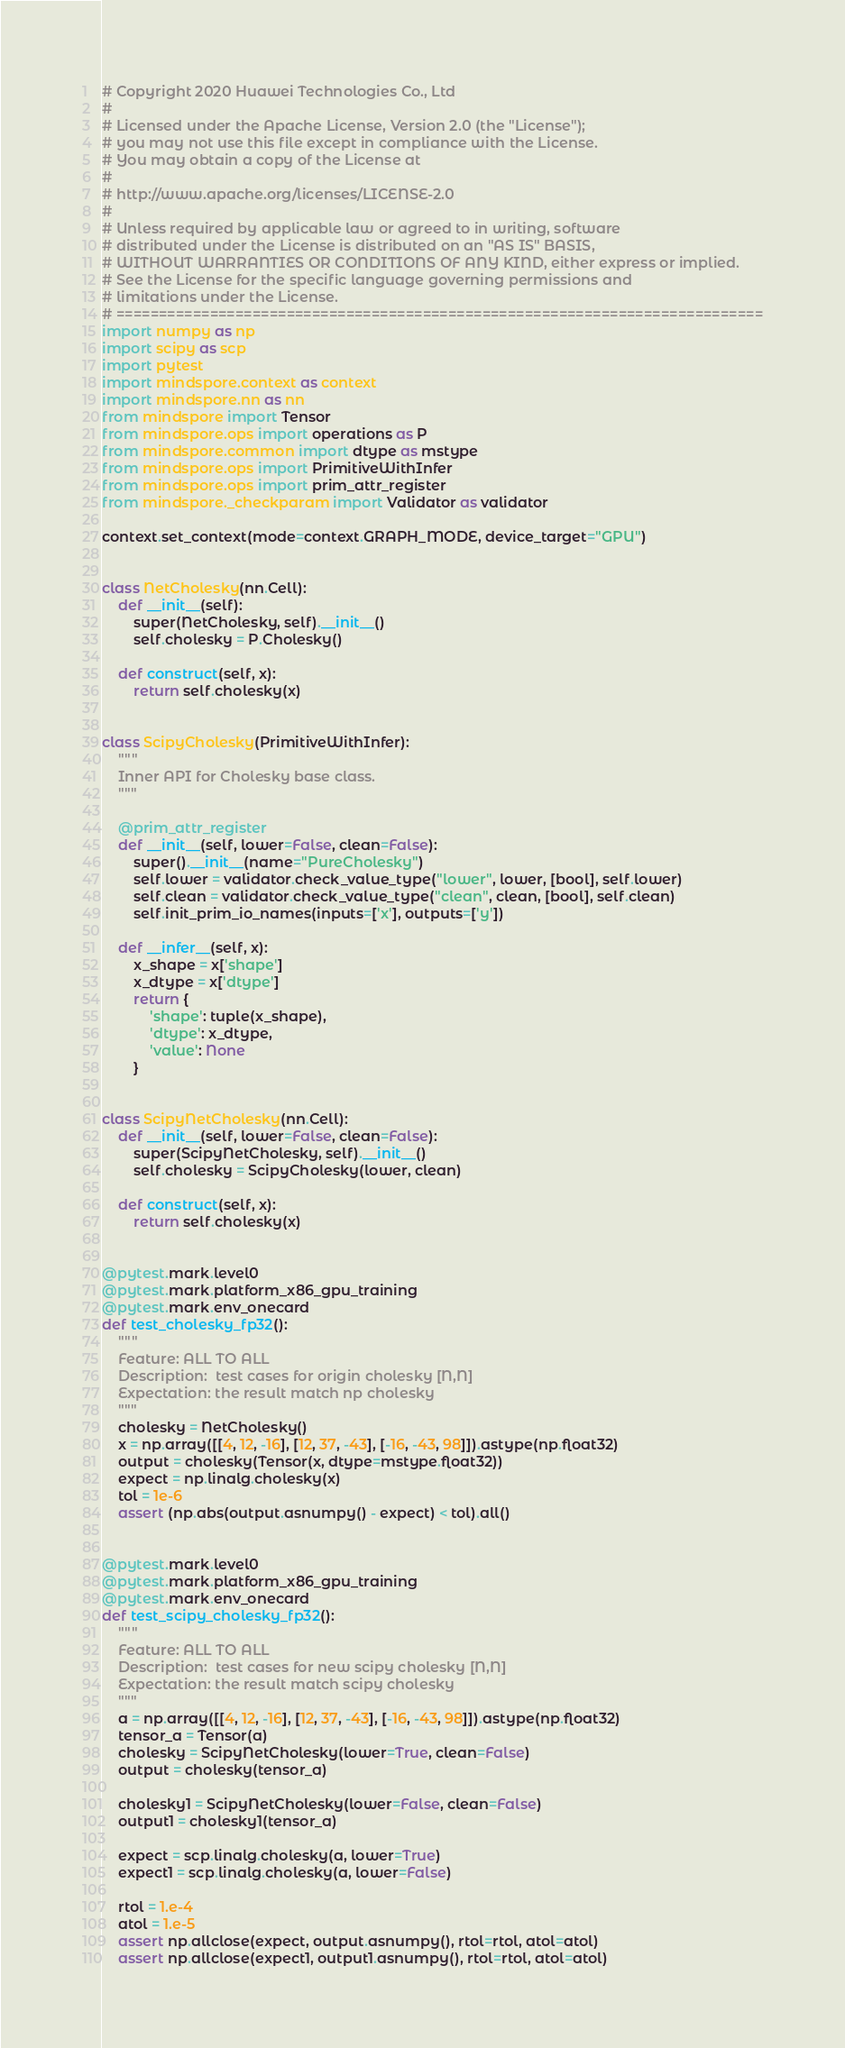<code> <loc_0><loc_0><loc_500><loc_500><_Python_># Copyright 2020 Huawei Technologies Co., Ltd
#
# Licensed under the Apache License, Version 2.0 (the "License");
# you may not use this file except in compliance with the License.
# You may obtain a copy of the License at
#
# http://www.apache.org/licenses/LICENSE-2.0
#
# Unless required by applicable law or agreed to in writing, software
# distributed under the License is distributed on an "AS IS" BASIS,
# WITHOUT WARRANTIES OR CONDITIONS OF ANY KIND, either express or implied.
# See the License for the specific language governing permissions and
# limitations under the License.
# ============================================================================
import numpy as np
import scipy as scp
import pytest
import mindspore.context as context
import mindspore.nn as nn
from mindspore import Tensor
from mindspore.ops import operations as P
from mindspore.common import dtype as mstype
from mindspore.ops import PrimitiveWithInfer
from mindspore.ops import prim_attr_register
from mindspore._checkparam import Validator as validator

context.set_context(mode=context.GRAPH_MODE, device_target="GPU")


class NetCholesky(nn.Cell):
    def __init__(self):
        super(NetCholesky, self).__init__()
        self.cholesky = P.Cholesky()

    def construct(self, x):
        return self.cholesky(x)


class ScipyCholesky(PrimitiveWithInfer):
    """
    Inner API for Cholesky base class.
    """

    @prim_attr_register
    def __init__(self, lower=False, clean=False):
        super().__init__(name="PureCholesky")
        self.lower = validator.check_value_type("lower", lower, [bool], self.lower)
        self.clean = validator.check_value_type("clean", clean, [bool], self.clean)
        self.init_prim_io_names(inputs=['x'], outputs=['y'])

    def __infer__(self, x):
        x_shape = x['shape']
        x_dtype = x['dtype']
        return {
            'shape': tuple(x_shape),
            'dtype': x_dtype,
            'value': None
        }


class ScipyNetCholesky(nn.Cell):
    def __init__(self, lower=False, clean=False):
        super(ScipyNetCholesky, self).__init__()
        self.cholesky = ScipyCholesky(lower, clean)

    def construct(self, x):
        return self.cholesky(x)


@pytest.mark.level0
@pytest.mark.platform_x86_gpu_training
@pytest.mark.env_onecard
def test_cholesky_fp32():
    """
    Feature: ALL TO ALL
    Description:  test cases for origin cholesky [N,N]
    Expectation: the result match np cholesky
    """
    cholesky = NetCholesky()
    x = np.array([[4, 12, -16], [12, 37, -43], [-16, -43, 98]]).astype(np.float32)
    output = cholesky(Tensor(x, dtype=mstype.float32))
    expect = np.linalg.cholesky(x)
    tol = 1e-6
    assert (np.abs(output.asnumpy() - expect) < tol).all()


@pytest.mark.level0
@pytest.mark.platform_x86_gpu_training
@pytest.mark.env_onecard
def test_scipy_cholesky_fp32():
    """
    Feature: ALL TO ALL
    Description:  test cases for new scipy cholesky [N,N]
    Expectation: the result match scipy cholesky
    """
    a = np.array([[4, 12, -16], [12, 37, -43], [-16, -43, 98]]).astype(np.float32)
    tensor_a = Tensor(a)
    cholesky = ScipyNetCholesky(lower=True, clean=False)
    output = cholesky(tensor_a)

    cholesky1 = ScipyNetCholesky(lower=False, clean=False)
    output1 = cholesky1(tensor_a)

    expect = scp.linalg.cholesky(a, lower=True)
    expect1 = scp.linalg.cholesky(a, lower=False)

    rtol = 1.e-4
    atol = 1.e-5
    assert np.allclose(expect, output.asnumpy(), rtol=rtol, atol=atol)
    assert np.allclose(expect1, output1.asnumpy(), rtol=rtol, atol=atol)
</code> 